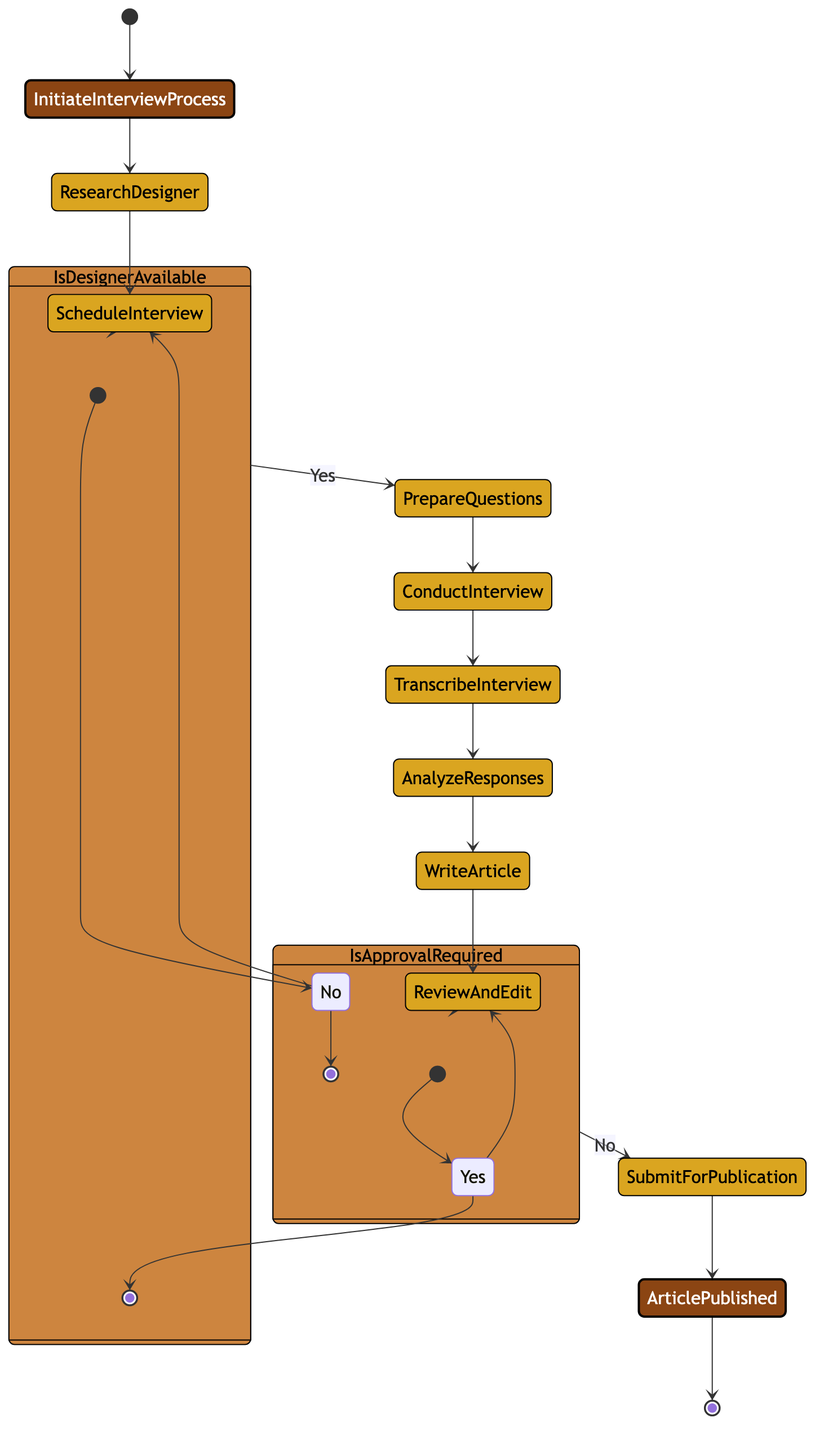What is the starting point of the interview process? The starting point is labeled "Initiate Interview Process," which is the entry point to begin the sequence of activities outlined in the diagram.
Answer: Initiate Interview Process How many activities are shown in the diagram? There are eight activities listed in the diagram, each detailing a specific step in the process of interviewing the fashion designer.
Answer: Eight What is the outcome of the decision "Is Designer Available?" if the answer is "No"? If the answer is "No," the flow leads back to "Schedule Interview," indicating that the process needs to revisit scheduling to find an available time with the designer.
Answer: Schedule Interview What activity follows "Analyze Responses"? The activity that directly follows "Analyze Responses" is "Write Article," which indicates that after analyzing the designer's responses, the next step is to create a written piece.
Answer: Write Article Is approval required after "Review and Edit"? Yes, the flow branches into the decision "Is Approval Required?" which signifies that after reviewing and editing, it must be determined if the designer's PR team needs to approve the content.
Answer: Yes What connects "Conduct Interview" and "Transcribe Interview"? The connection between "Conduct Interview" and "Transcribe Interview" is a directed flow indicating that after the interview, the next logical step is to transcribe the captured responses.
Answer: Transcribe Interview If the designer is available, what activity comes after "Prepare Questions"? If the designer is available, the next activity is "Conduct Interview," meaning that once the questions are prepared, the actual interview can take place.
Answer: Conduct Interview What happens to the published article at the end of the process? The outcome is "Article Published," which signifies the completion of the interview process and its transition into publication.
Answer: Article Published 